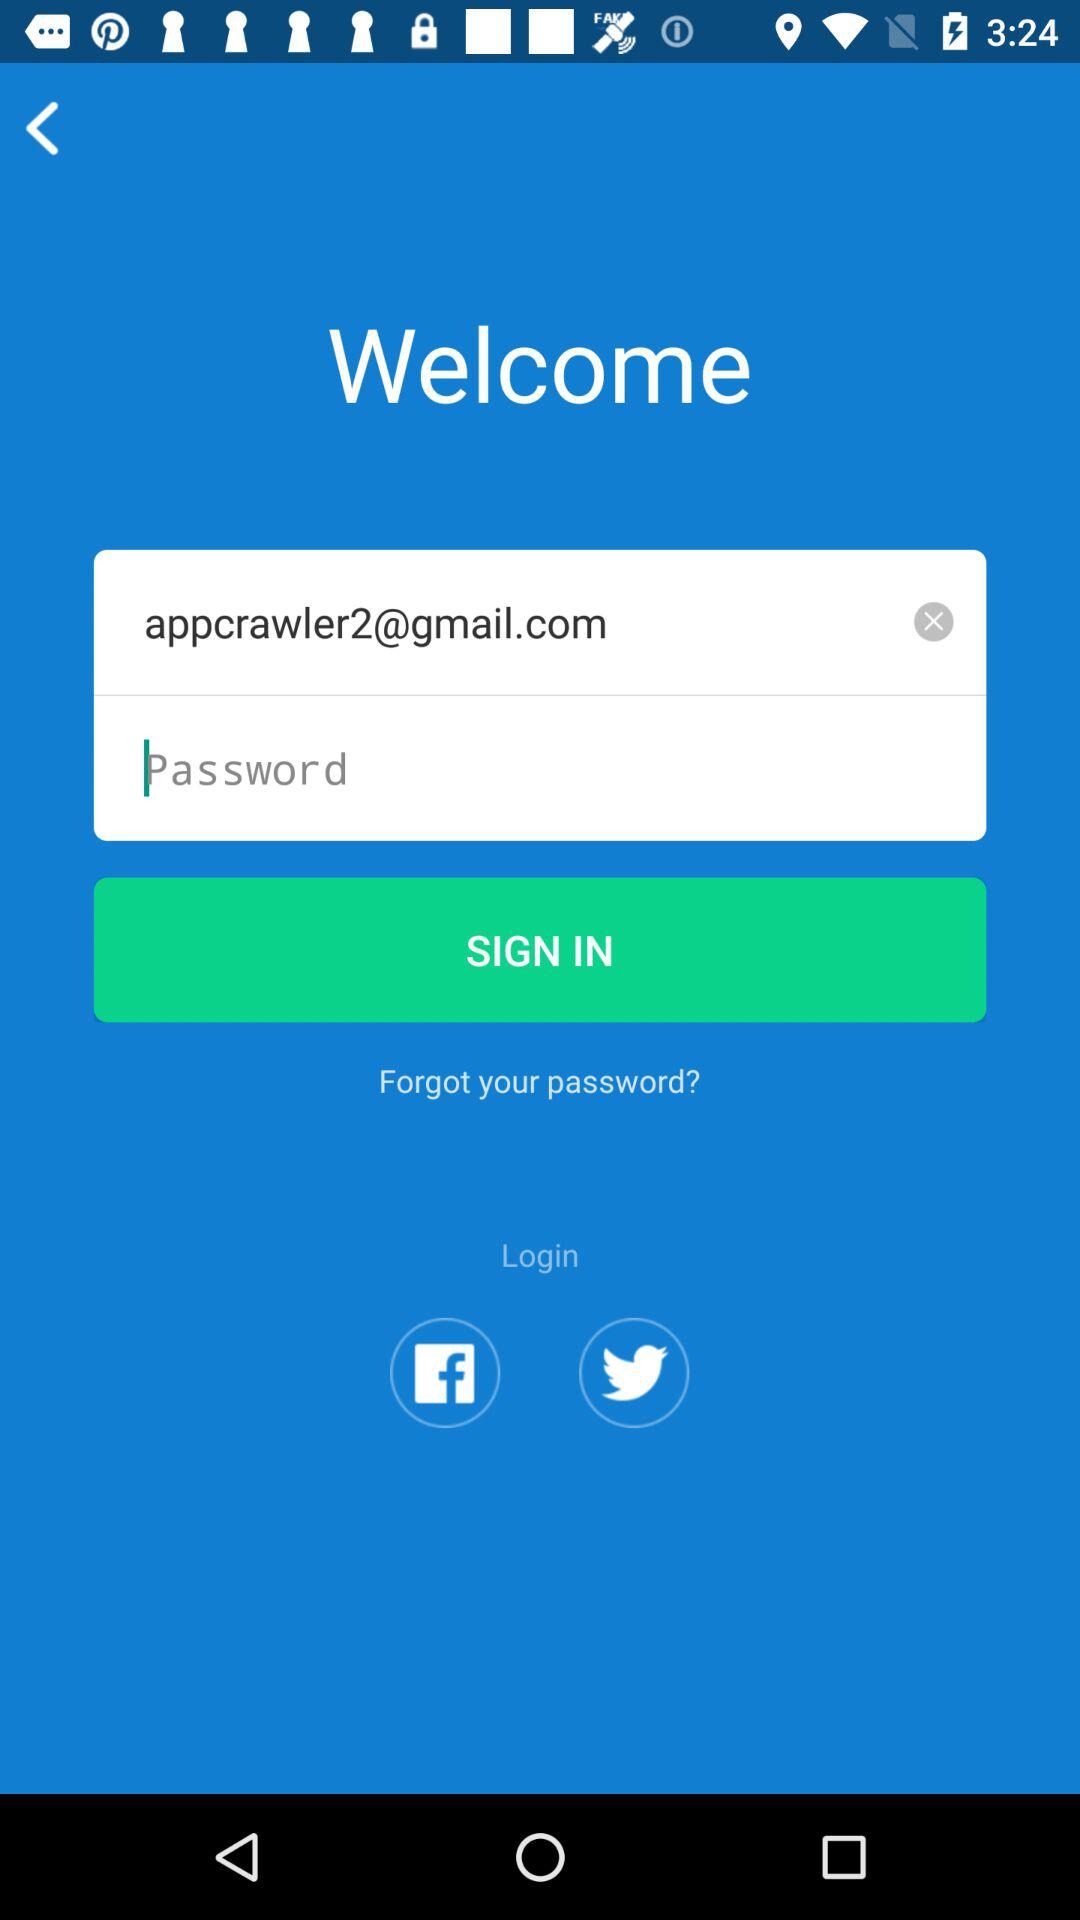How many input fields are there for the login form?
Answer the question using a single word or phrase. 2 